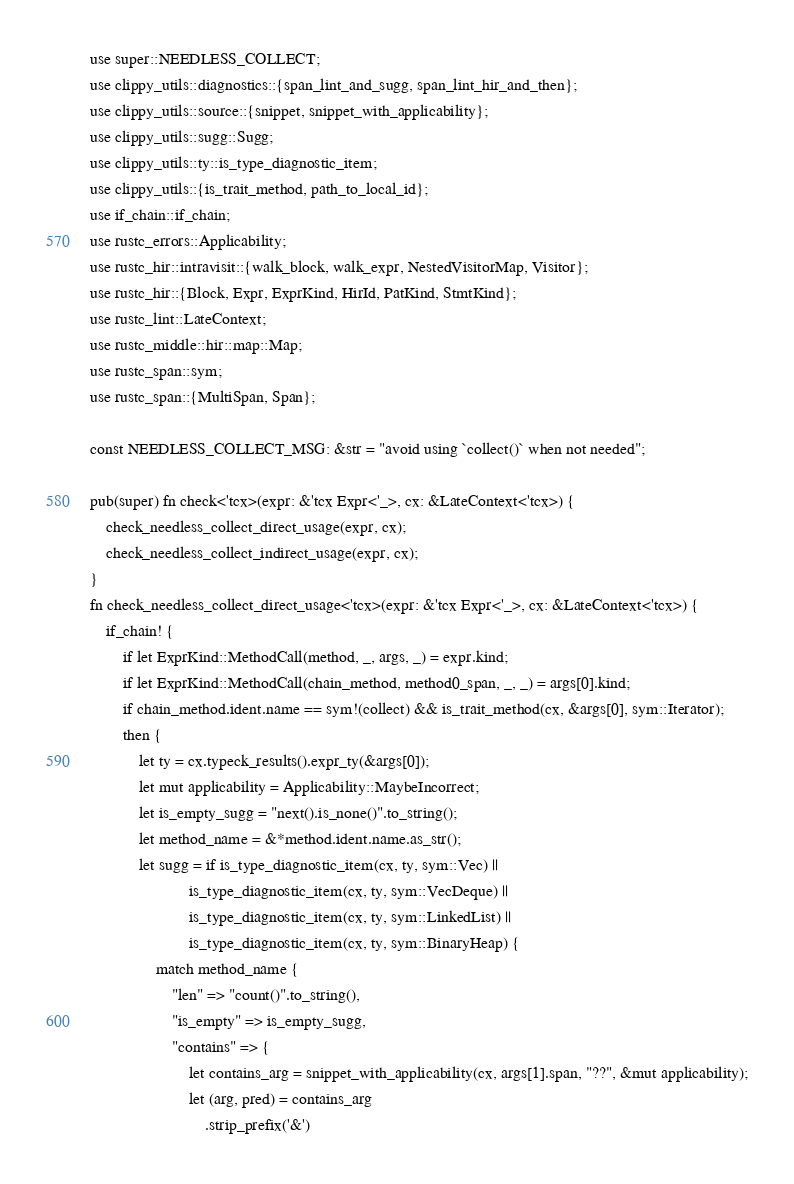Convert code to text. <code><loc_0><loc_0><loc_500><loc_500><_Rust_>use super::NEEDLESS_COLLECT;
use clippy_utils::diagnostics::{span_lint_and_sugg, span_lint_hir_and_then};
use clippy_utils::source::{snippet, snippet_with_applicability};
use clippy_utils::sugg::Sugg;
use clippy_utils::ty::is_type_diagnostic_item;
use clippy_utils::{is_trait_method, path_to_local_id};
use if_chain::if_chain;
use rustc_errors::Applicability;
use rustc_hir::intravisit::{walk_block, walk_expr, NestedVisitorMap, Visitor};
use rustc_hir::{Block, Expr, ExprKind, HirId, PatKind, StmtKind};
use rustc_lint::LateContext;
use rustc_middle::hir::map::Map;
use rustc_span::sym;
use rustc_span::{MultiSpan, Span};

const NEEDLESS_COLLECT_MSG: &str = "avoid using `collect()` when not needed";

pub(super) fn check<'tcx>(expr: &'tcx Expr<'_>, cx: &LateContext<'tcx>) {
    check_needless_collect_direct_usage(expr, cx);
    check_needless_collect_indirect_usage(expr, cx);
}
fn check_needless_collect_direct_usage<'tcx>(expr: &'tcx Expr<'_>, cx: &LateContext<'tcx>) {
    if_chain! {
        if let ExprKind::MethodCall(method, _, args, _) = expr.kind;
        if let ExprKind::MethodCall(chain_method, method0_span, _, _) = args[0].kind;
        if chain_method.ident.name == sym!(collect) && is_trait_method(cx, &args[0], sym::Iterator);
        then {
            let ty = cx.typeck_results().expr_ty(&args[0]);
            let mut applicability = Applicability::MaybeIncorrect;
            let is_empty_sugg = "next().is_none()".to_string();
            let method_name = &*method.ident.name.as_str();
            let sugg = if is_type_diagnostic_item(cx, ty, sym::Vec) ||
                        is_type_diagnostic_item(cx, ty, sym::VecDeque) ||
                        is_type_diagnostic_item(cx, ty, sym::LinkedList) ||
                        is_type_diagnostic_item(cx, ty, sym::BinaryHeap) {
                match method_name {
                    "len" => "count()".to_string(),
                    "is_empty" => is_empty_sugg,
                    "contains" => {
                        let contains_arg = snippet_with_applicability(cx, args[1].span, "??", &mut applicability);
                        let (arg, pred) = contains_arg
                            .strip_prefix('&')</code> 